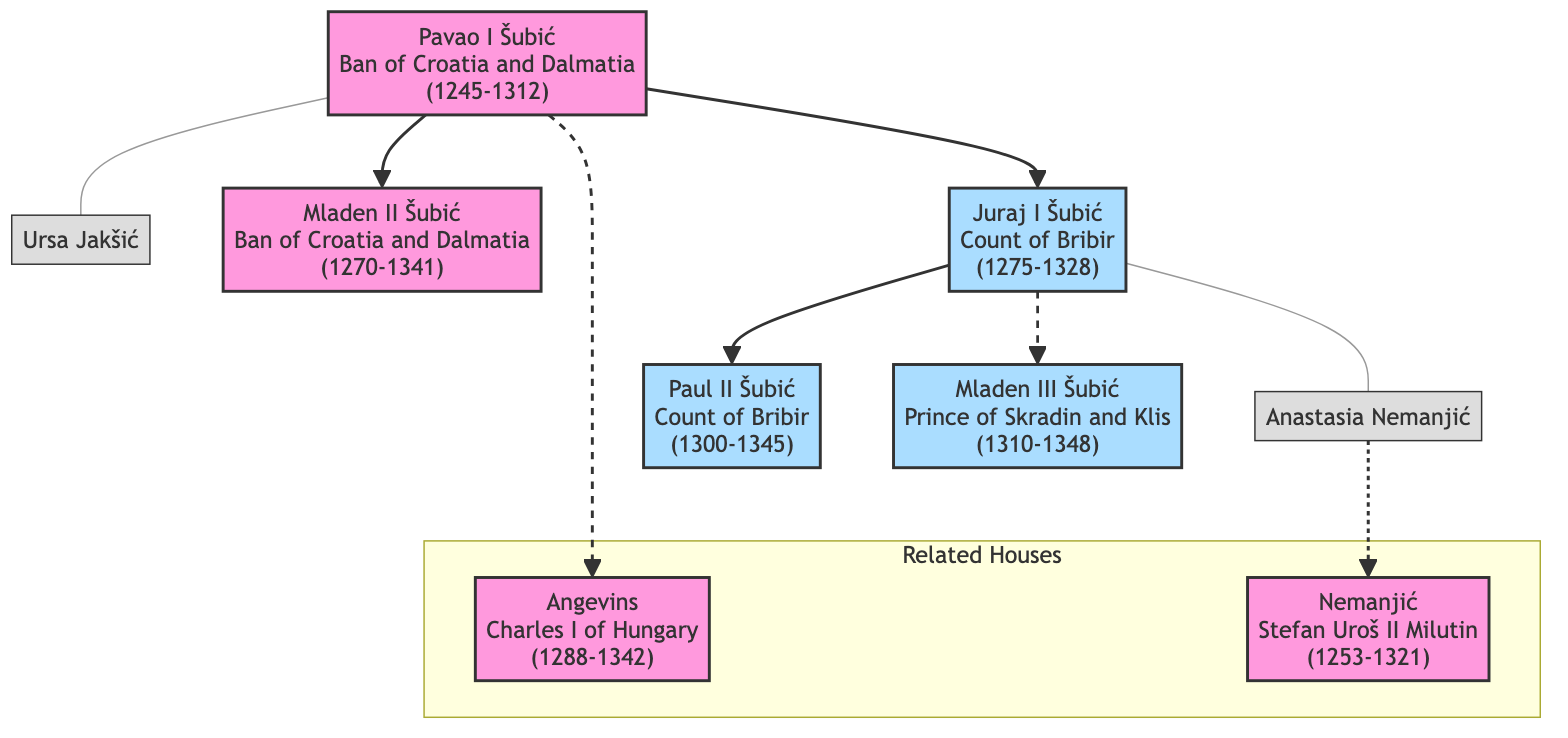What is the title of Pavao I Šubić? The diagram shows that Pavao I Šubić holds the title "Ban of Croatia and Dalmatia." This can be found directly under his name in the visual representation.
Answer: Ban of Croatia and Dalmatia Who was Juraj I Šubić’s spouse? In the family tree, the spouse of Juraj I Šubić is explicitly mentioned as Anastasia Nemanjić, indicated directly beside his name.
Answer: Anastasia Nemanjić How many children did Pavao I Šubić have? The diagram lists two children under Pavao I Šubić's node, Mladen II Šubić and Juraj I Šubić, indicating the count of his offspring.
Answer: 2 What notable action is Mladen II Šubić known for? The diagram highlights that Mladen II Šubić participated in the "Battle of Bliska," which is among his noteworthy actions listed next to his name.
Answer: Battle of Bliska Which noble house is connected to the Šubić family through marriage? The diagram indicates that the Šubić family is connected to the Nemanjić house through marriage, as shown by the dashed line connecting Juraj I Šubić and Anastasia Nemanjić.
Answer: Nemanjić What relation does Pavao I Šubić have with Charles I of Hungary? According to the diagram, Pavao I Šubić has a relationship of alliance with the Angevins, noted through the connection to Charles I of Hungary.
Answer: Alliance How many notable descendants does Juraj I Šubić have? The visual representation specifies that Juraj I Šubić has two notable descendants listed beneath him: Paul II Šubić and Mladen III Šubić.
Answer: 2 What title did Mladen III Šubić hold? The diagram clearly states that Mladen III Šubić is titled "Prince of Skradin and Klis," which is visible in the information presented under his node.
Answer: Prince of Skradin and Klis Who was the significant member of the Angevins mentioned? The family tree identifies Charles I of Hungary as a significant member of the Angevins, as indicated in the related noble houses section of the diagram.
Answer: Charles I of Hungary 